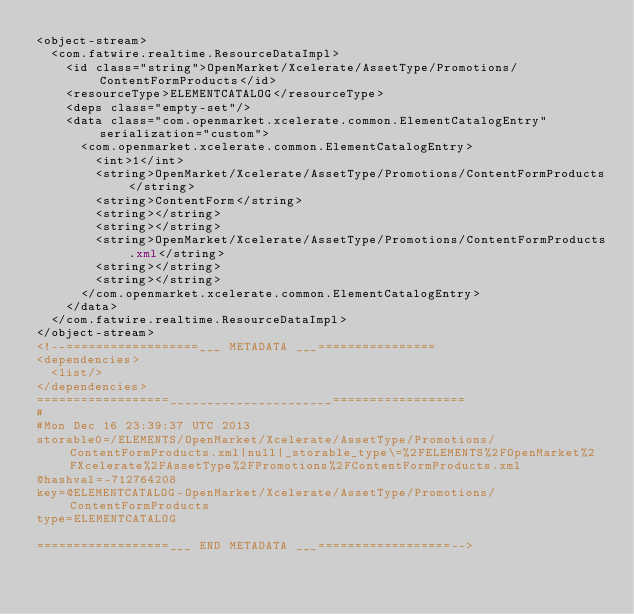<code> <loc_0><loc_0><loc_500><loc_500><_XML_><object-stream>
  <com.fatwire.realtime.ResourceDataImpl>
    <id class="string">OpenMarket/Xcelerate/AssetType/Promotions/ContentFormProducts</id>
    <resourceType>ELEMENTCATALOG</resourceType>
    <deps class="empty-set"/>
    <data class="com.openmarket.xcelerate.common.ElementCatalogEntry" serialization="custom">
      <com.openmarket.xcelerate.common.ElementCatalogEntry>
        <int>1</int>
        <string>OpenMarket/Xcelerate/AssetType/Promotions/ContentFormProducts</string>
        <string>ContentForm</string>
        <string></string>
        <string></string>
        <string>OpenMarket/Xcelerate/AssetType/Promotions/ContentFormProducts.xml</string>
        <string></string>
        <string></string>
      </com.openmarket.xcelerate.common.ElementCatalogEntry>
    </data>
  </com.fatwire.realtime.ResourceDataImpl>
</object-stream>
<!--==================___ METADATA ___================
<dependencies>
  <list/>
</dependencies>
==================______________________==================
#
#Mon Dec 16 23:39:37 UTC 2013
storable0=/ELEMENTS/OpenMarket/Xcelerate/AssetType/Promotions/ContentFormProducts.xml|null|_storable_type\=%2FELEMENTS%2FOpenMarket%2FXcelerate%2FAssetType%2FPromotions%2FContentFormProducts.xml
@hashval=-712764208
key=@ELEMENTCATALOG-OpenMarket/Xcelerate/AssetType/Promotions/ContentFormProducts
type=ELEMENTCATALOG

==================___ END METADATA ___==================-->
</code> 